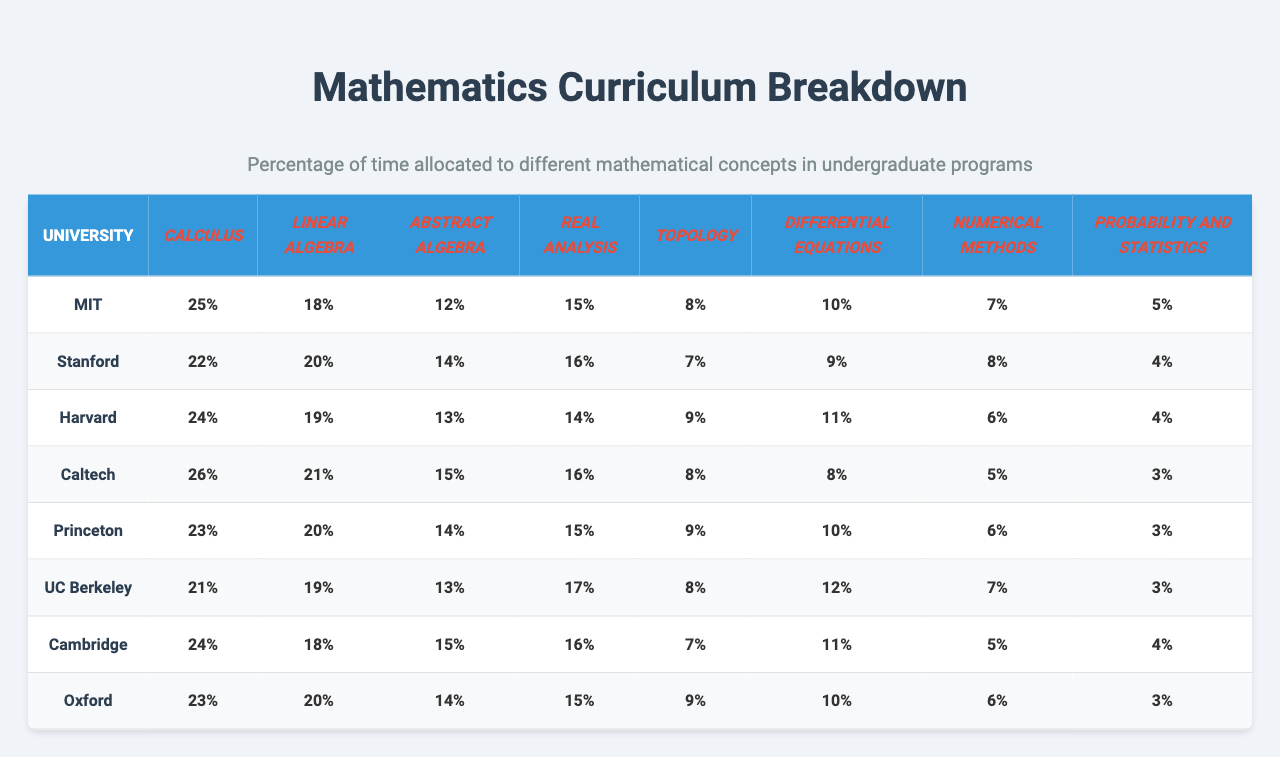What is the maximum allocation of time for Calculus among the universities? By examining the Calculus column in the table, we see the values are 25, 22, 24, 26, 23, 21, 24, and 23. The highest value is 26, attributed to Caltech.
Answer: 26 Which university has the lowest allocation of time for Probability and Statistics? Looking at the Probability and Statistics column, the values are 5, 4, 4, 3, 3, 3, 4, and 3. The lowest value is 3, and it is assigned to Caltech, Princeton, UC Berkeley, and Oxford.
Answer: Caltech, Princeton, UC Berkeley, and Oxford What is the average time allocation for Abstract Algebra across all universities? We sum the values for Abstract Algebra: 12 + 14 + 13 + 15 + 14 + 13 + 15 + 14 = 104. Dividing by the number of universities (8), we find the average is 104 / 8 = 13.
Answer: 13 Is there a university that allocates more time to Real Analysis than to Linear Algebra? We compare values between the Real Analysis and Linear Algebra columns. The comparisons show that UC Berkeley (Real Analysis: 17, Linear Algebra: 19) is the only university where Real Analysis has a higher allocation; therefore, the answer is no.
Answer: No Which university has the most even distribution of time allocation across all mathematical concepts? To find this, we can compare the range (the difference between the maximum and minimum) of each university's concept allocation. By calculating these ranges for each university, we find that UC Berkeley has the smallest range: 17 - 5 = 12.
Answer: UC Berkeley What is the total allocation of time for Differential Equations across all universities? By summing the values in the Differential Equations column: 10 + 9 + 11 + 8 + 10 + 12 + 11 + 10 = 81, we find the total time allocation.
Answer: 81 Which mathematical concept has the highest average time allocation among these universities? First, we find the average for each concept: Calculus = 23.25, Linear Algebra = 19.25, Abstract Algebra = 14, Real Analysis = 15.5, Topology = 8, Differential Equations = 10, Numerical Methods = 6.5, Probability and Statistics = 3.75. The highest average is for Calculus.
Answer: Calculus Among all universities, which concept has the least time allocated, and what is that value? Observing the table, we find that Probability and Statistics has the lowest value at 3 for several universities.
Answer: 3 What is the difference in time allocation for Topology between MIT and Princeton? The Topology values for MIT and Princeton are 8 and 9, respectively. The difference is calculated as 9 - 8 = 1.
Answer: 1 How does the total time allocation for Probability and Statistics compare to that of Differential Equations? The total for Probability and Statistics is 32 (5 + 4 + 4 + 3 + 3 + 3 + 4 + 3), while for Differential Equations it is 81 (as calculated earlier). We see that 32 < 81.
Answer: Probability and Statistics has less allocation 